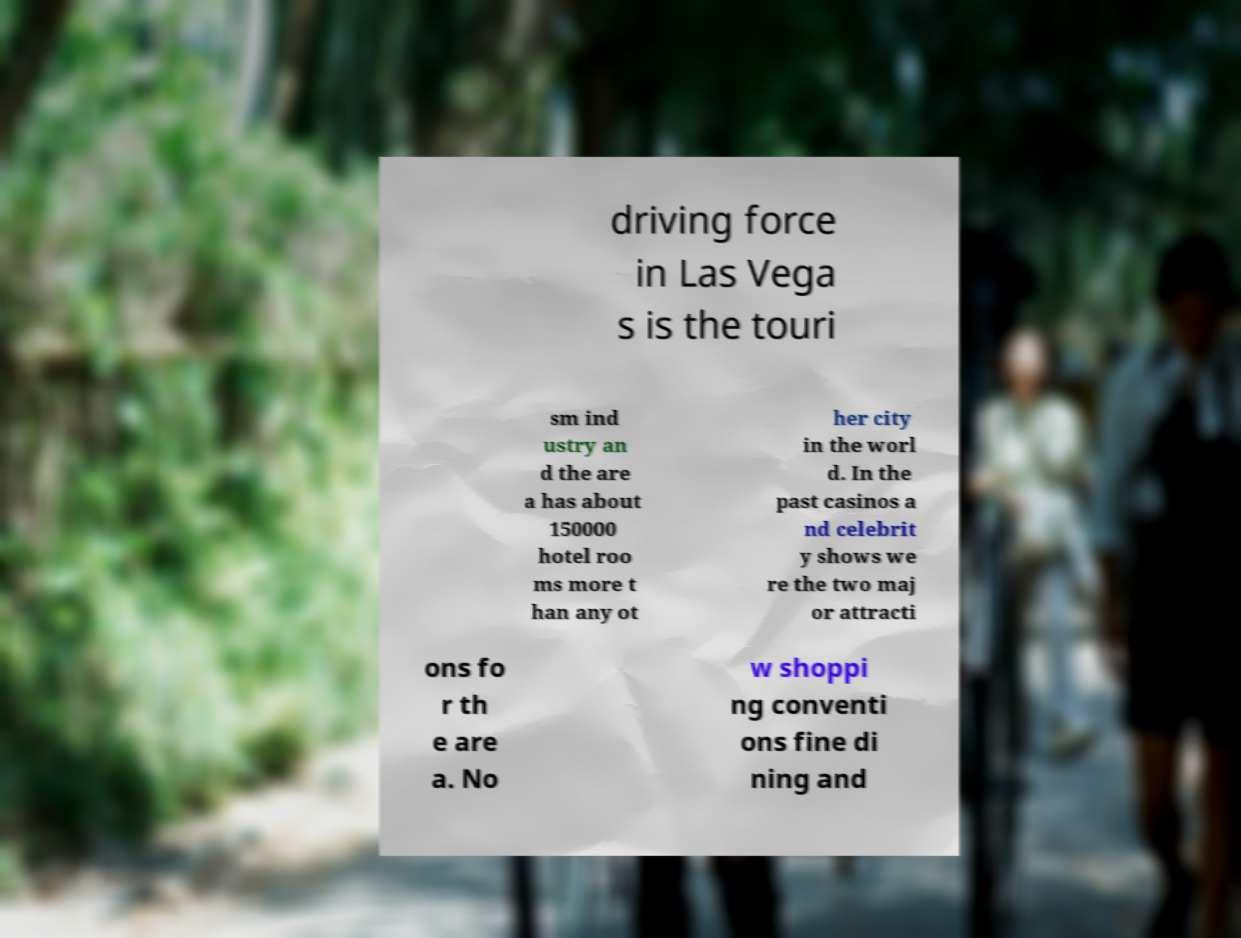For documentation purposes, I need the text within this image transcribed. Could you provide that? driving force in Las Vega s is the touri sm ind ustry an d the are a has about 150000 hotel roo ms more t han any ot her city in the worl d. In the past casinos a nd celebrit y shows we re the two maj or attracti ons fo r th e are a. No w shoppi ng conventi ons fine di ning and 